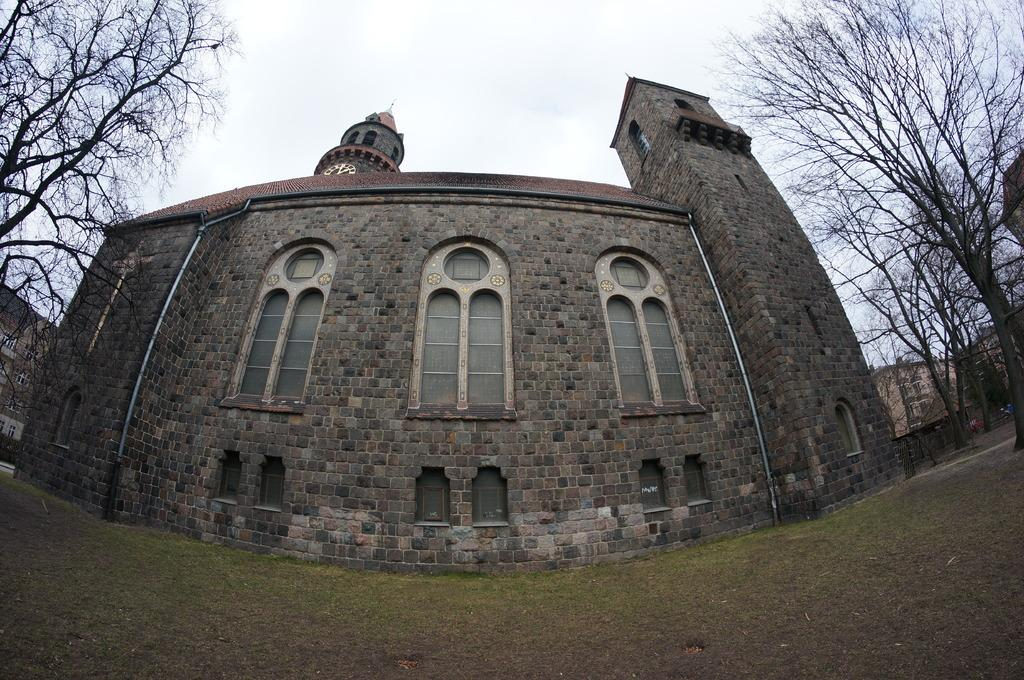What type of surface is visible in the image? There is ground visible in the image. What type of vegetation is present on the ground? There is grass on the ground. What other natural elements can be seen in the image? There are trees in the image. What type of man-made structure is present in the image? There is a building in the image. What feature of the building is mentioned in the facts? The building has windows. What is visible in the background of the image? The sky is visible in the background of the image. How many gloves are being used to maintain peace in the image? There are no gloves or references to peace in the image. 